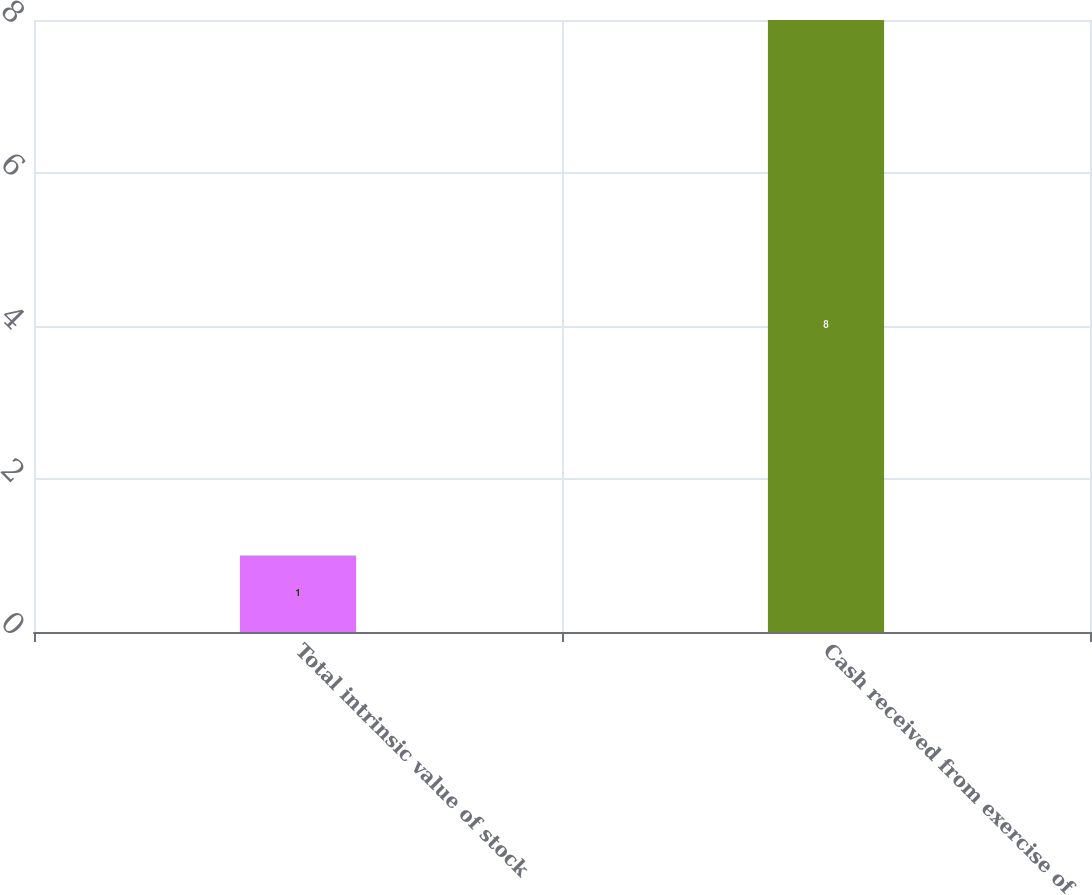Convert chart to OTSL. <chart><loc_0><loc_0><loc_500><loc_500><bar_chart><fcel>Total intrinsic value of stock<fcel>Cash received from exercise of<nl><fcel>1<fcel>8<nl></chart> 